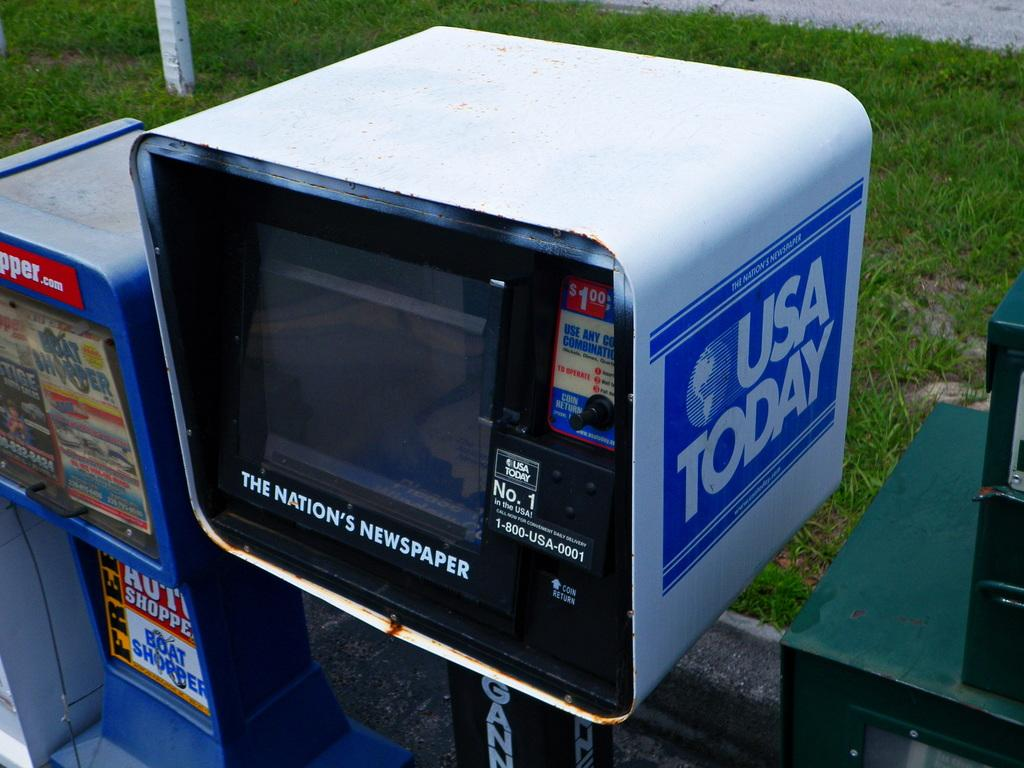Provide a one-sentence caption for the provided image. A row of USA Today newspaper vending machines on a sidewalk. 